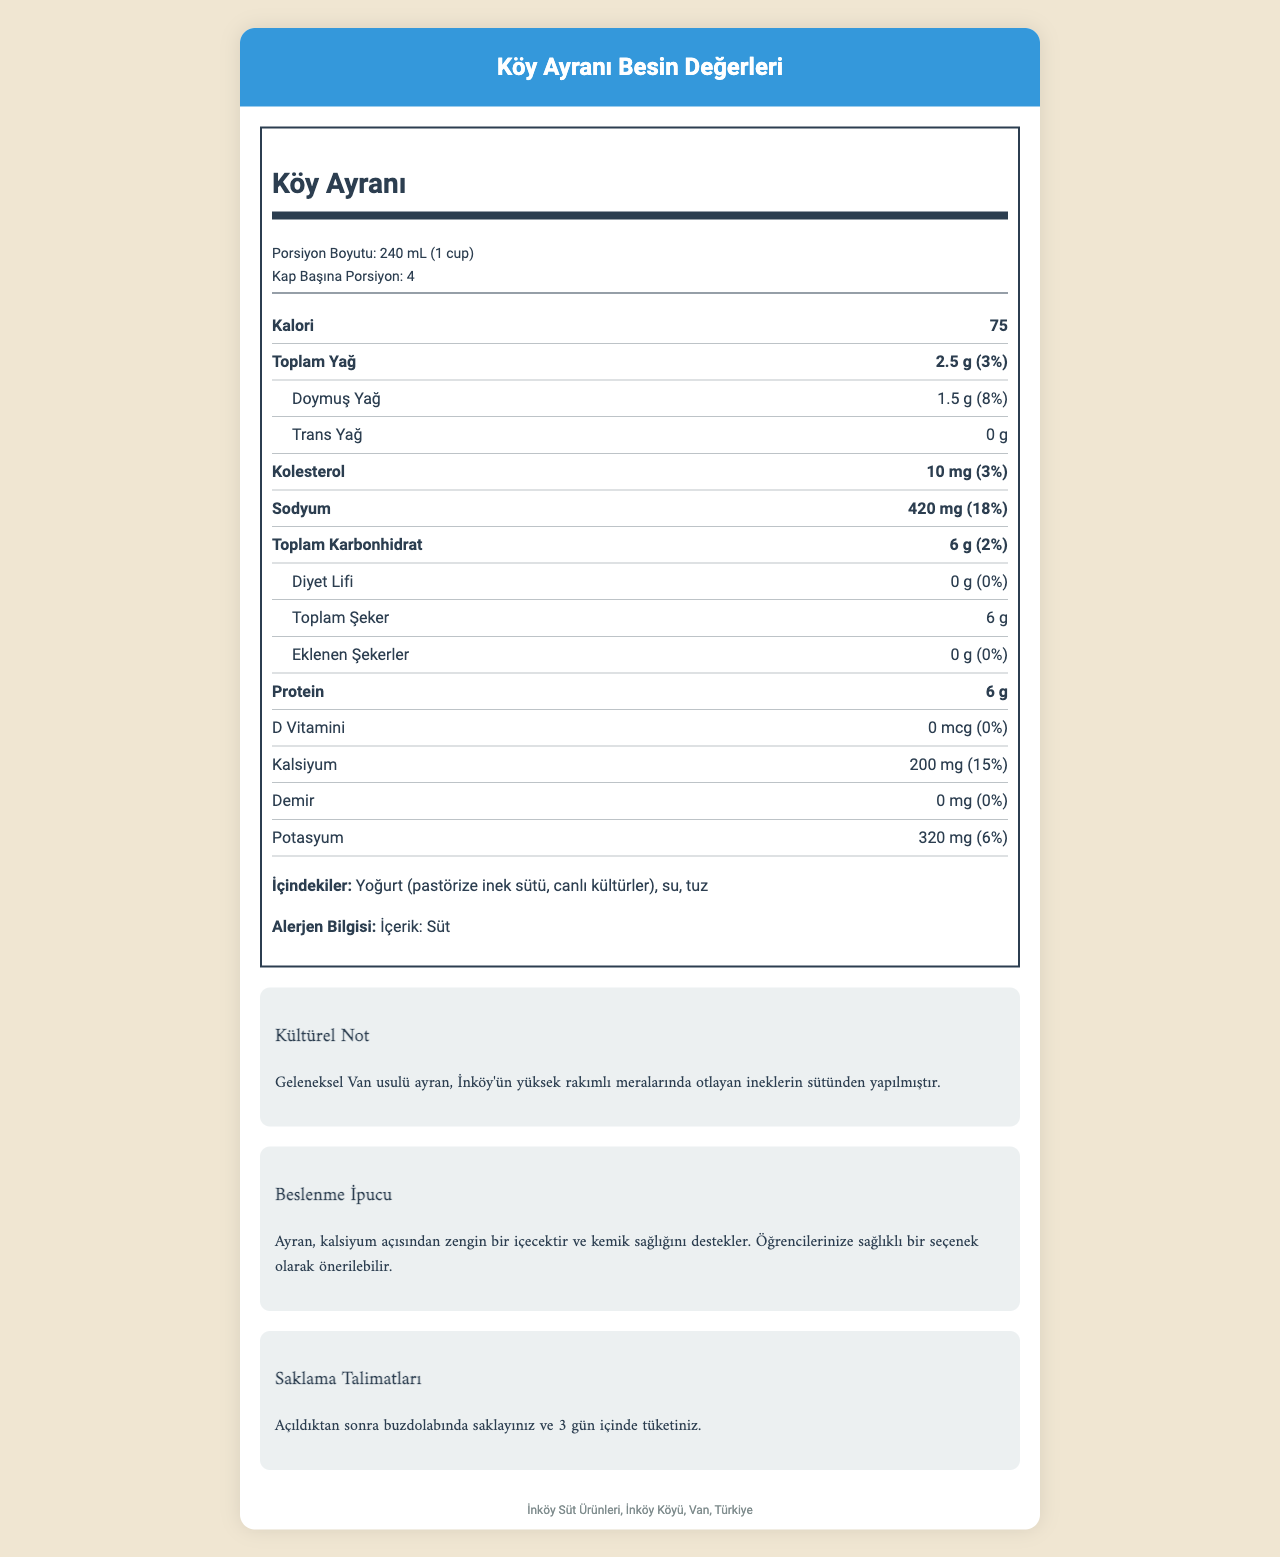who is the manufacturer of the ayran? The document lists the manufacturer information as "İnköy Süt Ürünleri."
Answer: İnköy Süt Ürünleri how many servings are there per container? The document specifies that there are 4 servings per container.
Answer: 4 what is the serving size for Köy Ayranı? The serving size is listed as "240 mL (1 cup)."
Answer: 240 mL (1 cup) how many grams of protein are in one serving? The document states that there are 6 grams of protein per serving.
Answer: 6 g what is the daily value percentage of calcium in one serving? According to the document, one serving contains 15% of the daily value for calcium.
Answer: 15% how much sodium is in one serving? A. 320 mg B. 420 mg C. 500 mg D. 210 mg The document shows that one serving contains 420 mg of sodium.
Answer: B which nutrient contributes 8% of the daily value in one serving? i. Cholesterol ii. Saturated Fat iii. Sodium iv. Total Fat Saturated fat contributes 8% of the daily value in one serving, as listed in the document.
Answer: ii is there any added sugar in Köy Ayranı? The document mentions that there are no added sugars in Köy Ayranı.
Answer: No is the ayran yogurt-based? True or False The ingredients section lists yogurt as a primary component, making the statement true.
Answer: True summarize the main nutritional components and benefits of Köy Ayranı. Köy Ayranı is a nutritious traditional drink with substantial amounts of protein, calcium, and sodium, beneficial for bone health. It is derived from high-quality yogurt and water with minimal processing.
Answer: Köy Ayranı, a traditional yogurt-based drink, has 75 calories per serving, with 2.5 g of total fat, 6 g of carbohydrates, and 6 g of protein. It's rich in calcium and sodium, making it a nutritious option. This drink supports bone health and is made from cows grazing in high-altitude pastures. what are the sources of live cultures in the drink? The document does not specify the sources of the live cultures beyond stating "canlı kültürler" in the ingredients list.
Answer: Cannot be determined 